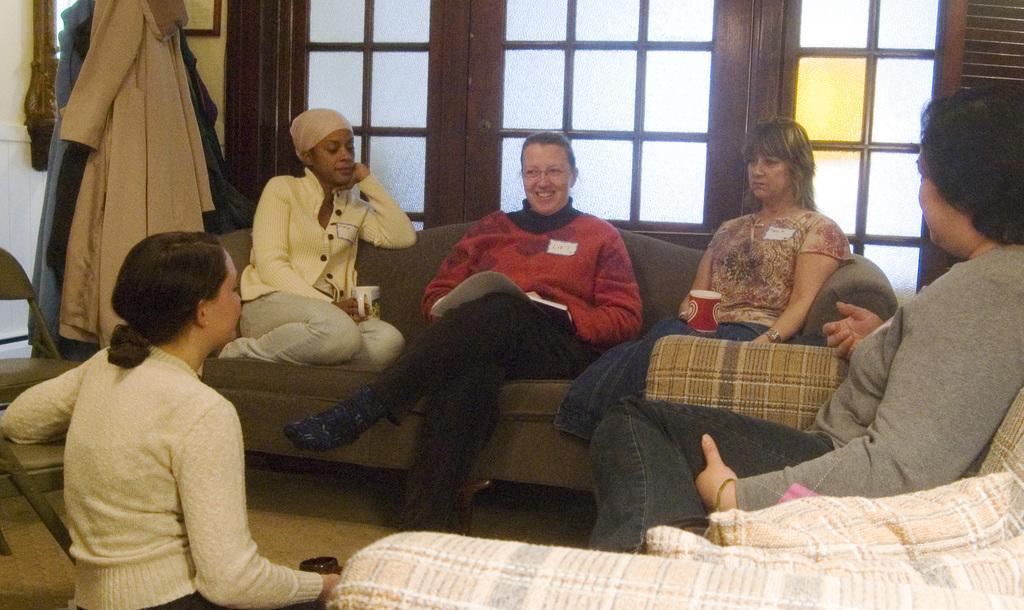Can you describe this image briefly? In the foreground of this image, there are woman sitting on the sofas holding cups and papers and also a woman sitting on the ground holding a cup. Beside her, there are chairs. Behind them, there are windows, coates and the wall. At the bottom, there are cushions. 